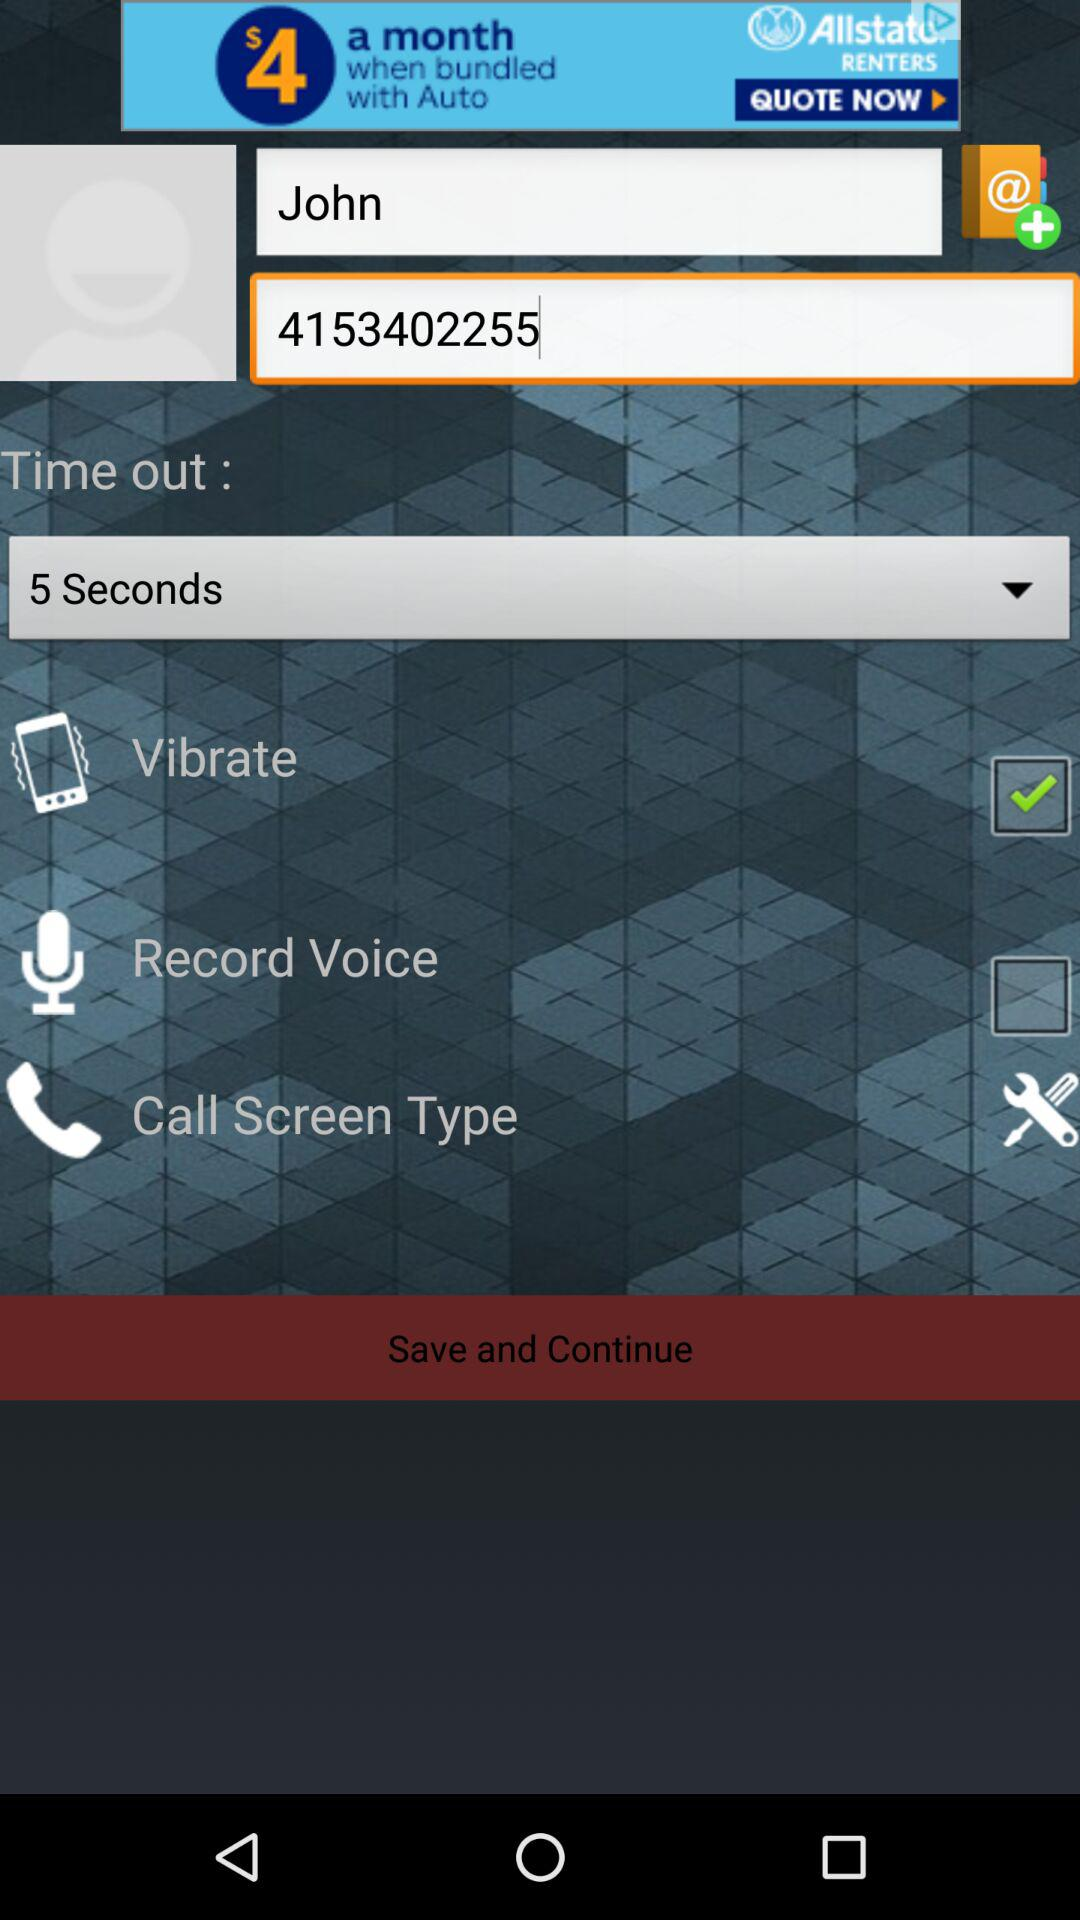What is the user's name? The user's name is John. 